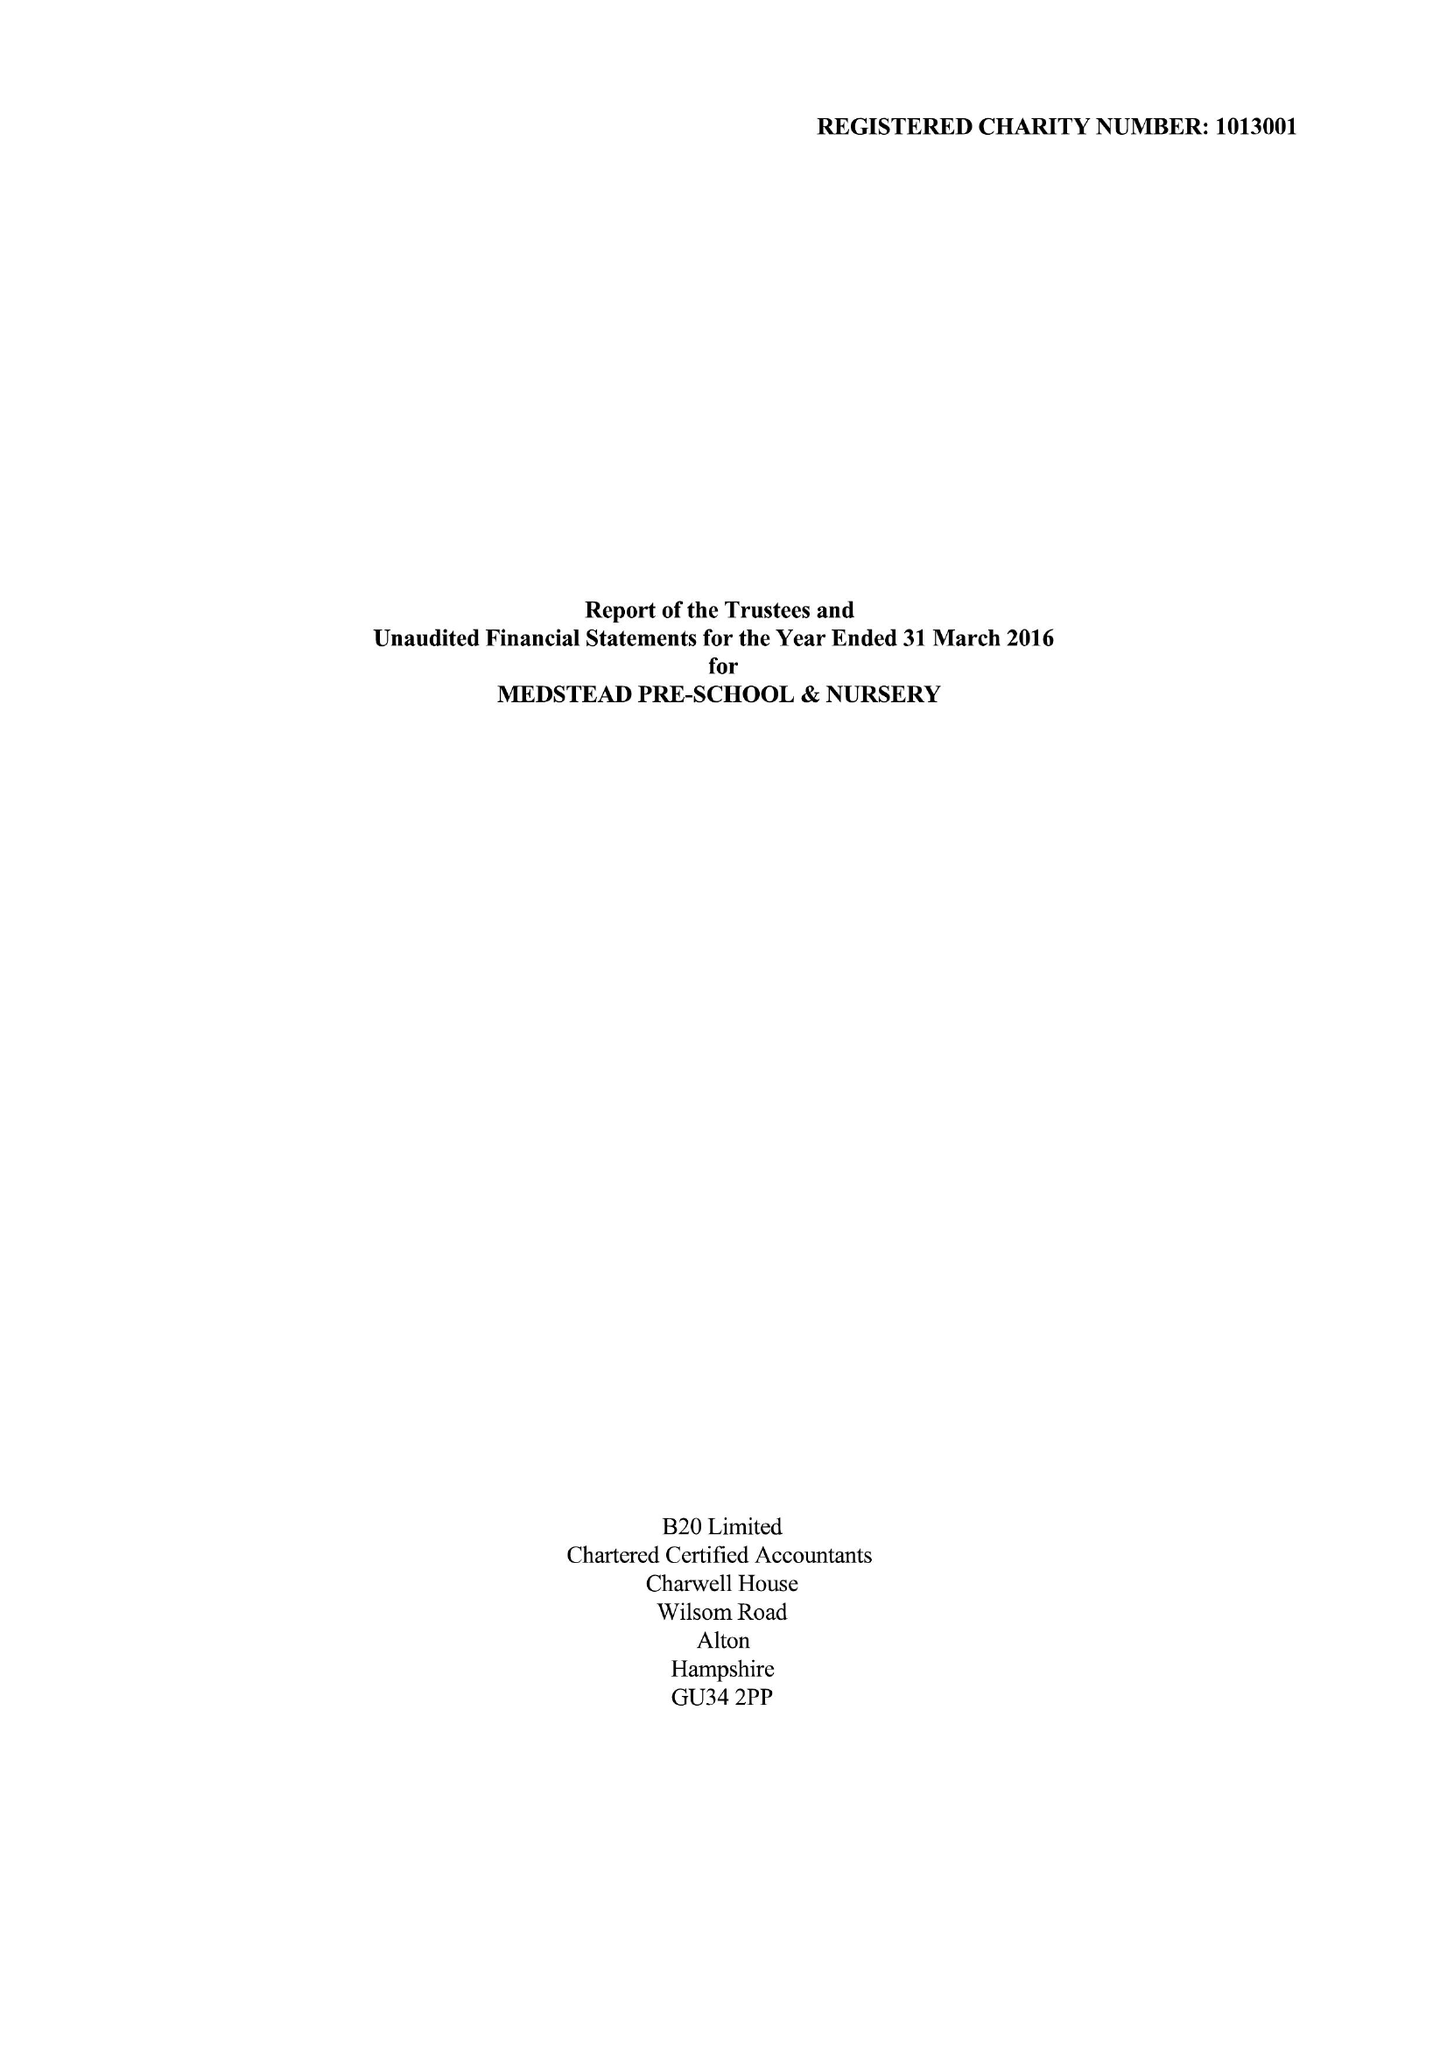What is the value for the report_date?
Answer the question using a single word or phrase. 2016-03-31 